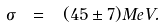Convert formula to latex. <formula><loc_0><loc_0><loc_500><loc_500>\sigma \ = \ ( 4 5 \pm 7 ) M e V .</formula> 